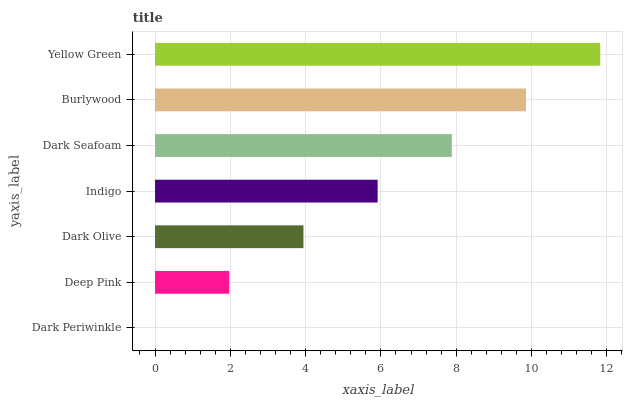Is Dark Periwinkle the minimum?
Answer yes or no. Yes. Is Yellow Green the maximum?
Answer yes or no. Yes. Is Deep Pink the minimum?
Answer yes or no. No. Is Deep Pink the maximum?
Answer yes or no. No. Is Deep Pink greater than Dark Periwinkle?
Answer yes or no. Yes. Is Dark Periwinkle less than Deep Pink?
Answer yes or no. Yes. Is Dark Periwinkle greater than Deep Pink?
Answer yes or no. No. Is Deep Pink less than Dark Periwinkle?
Answer yes or no. No. Is Indigo the high median?
Answer yes or no. Yes. Is Indigo the low median?
Answer yes or no. Yes. Is Dark Seafoam the high median?
Answer yes or no. No. Is Burlywood the low median?
Answer yes or no. No. 